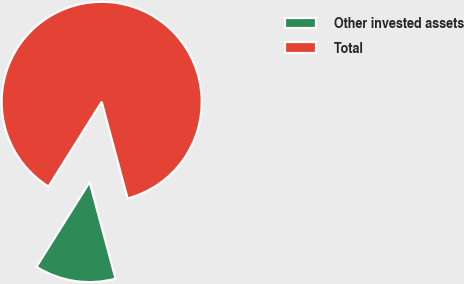<chart> <loc_0><loc_0><loc_500><loc_500><pie_chart><fcel>Other invested assets<fcel>Total<nl><fcel>13.09%<fcel>86.91%<nl></chart> 